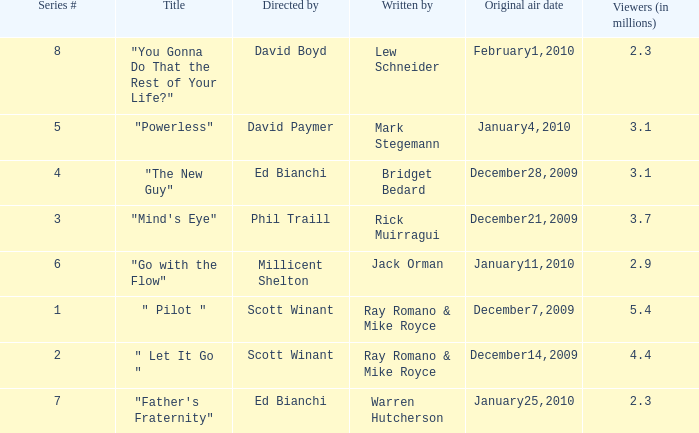How many viewers (in millions) did episode 1 have? 5.4. 